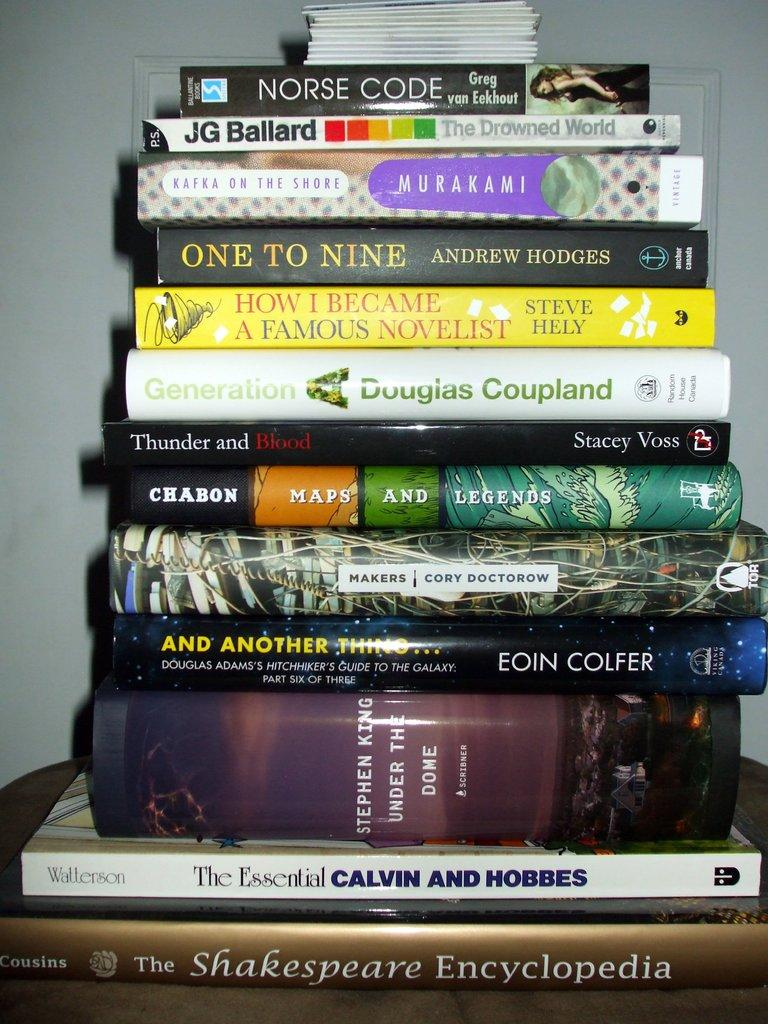<image>
Provide a brief description of the given image. A stack of books with Norse Code by Greg van Eekout on top. 